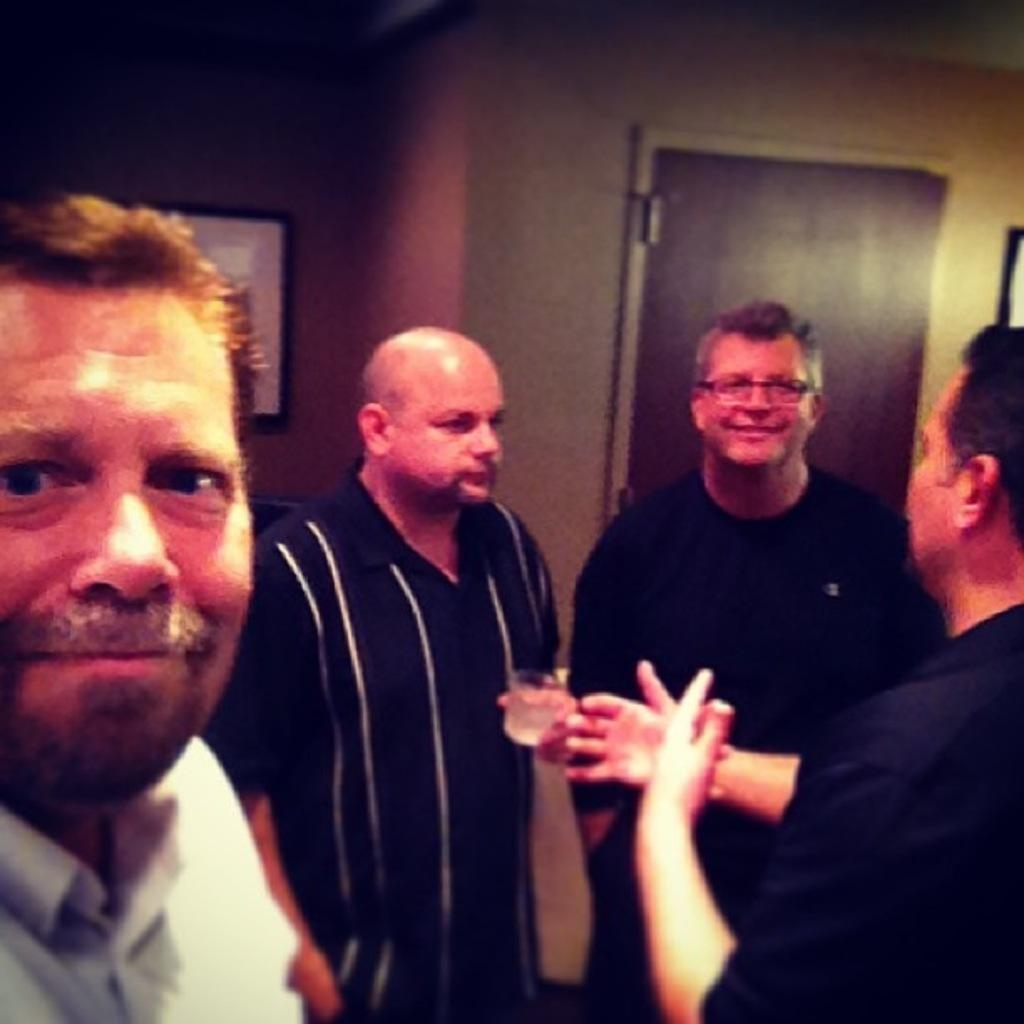Who or what can be seen in the image? There are people in the image. What is present on the wall in the background of the image? There is a frame on the wall in the background of the image. What architectural feature is visible in the background of the image? There is a door in the background of the image. What is the distance between the wheel and the boundary in the image? There is no wheel or boundary present in the image. 